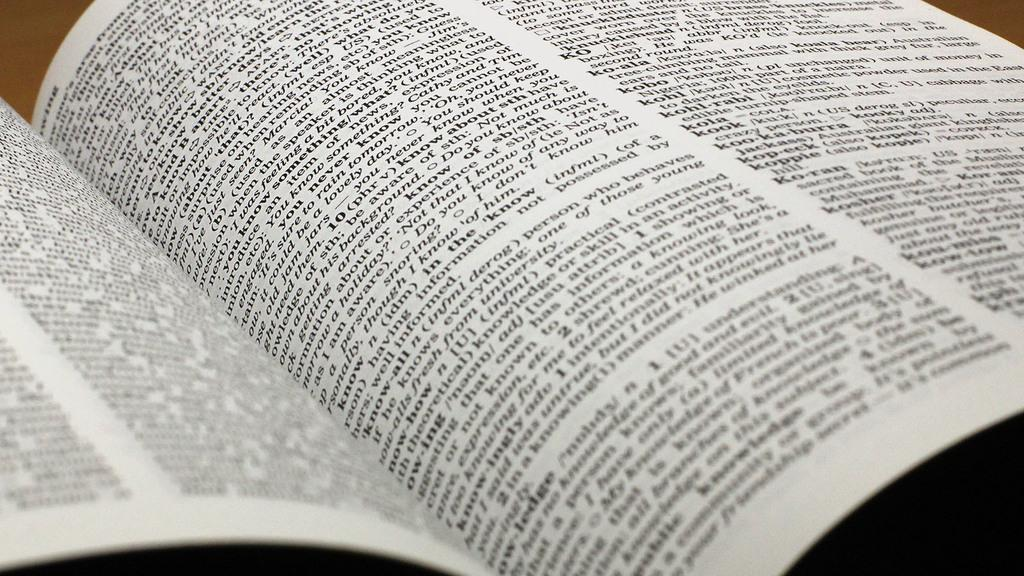<image>
Relay a brief, clear account of the picture shown. The dictionary is open to the page with the word know. 